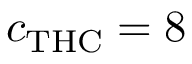Convert formula to latex. <formula><loc_0><loc_0><loc_500><loc_500>c _ { T H C } = 8</formula> 